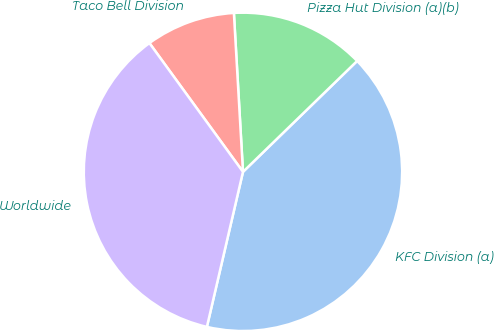Convert chart to OTSL. <chart><loc_0><loc_0><loc_500><loc_500><pie_chart><fcel>KFC Division (a)<fcel>Pizza Hut Division (a)(b)<fcel>Taco Bell Division<fcel>Worldwide<nl><fcel>40.91%<fcel>13.64%<fcel>9.09%<fcel>36.36%<nl></chart> 